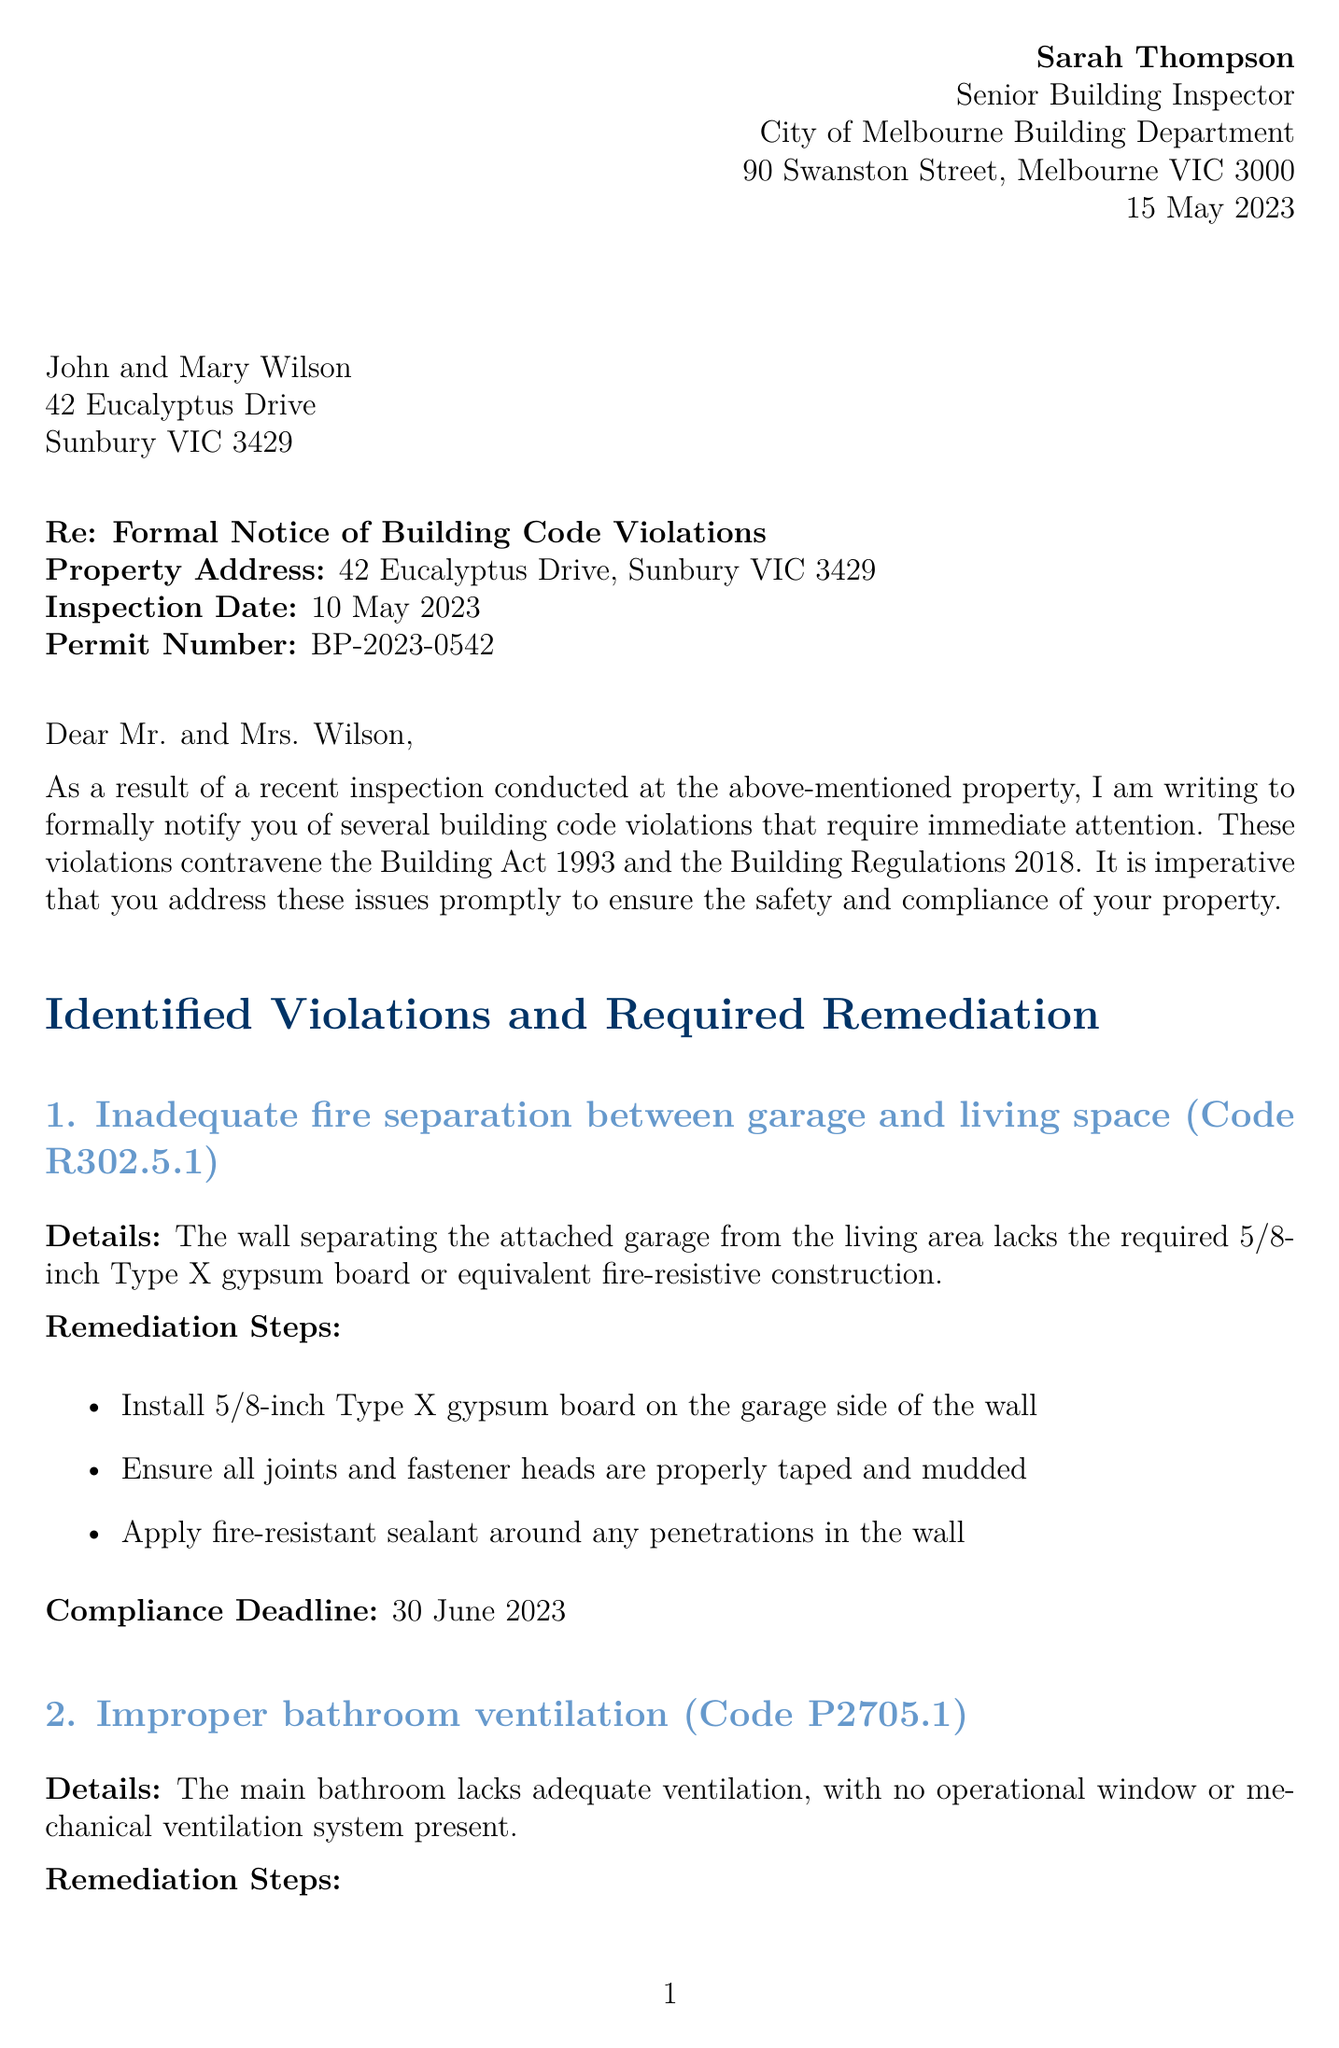What is the inspector's name? The inspector's name is listed at the top of the document.
Answer: Sarah Thompson What is the date of the letter? The date of the letter is indicated at the start of the document.
Answer: 15 May 2023 What is the property owner's name? The property owner's name is mentioned in the property details section.
Answer: John and Mary Wilson What is the code for the first violation? The first violation is labeled with a specific building code in the letter.
Answer: R302.5.1 What is the compliance deadline for the bathroom ventilation violation? The compliance deadline is specified in relation to the second violation.
Answer: 15 July 2023 How many remediation steps are required for the electrical outlets issue? The number of remediation steps can be counted from the section detailing that violation.
Answer: Three What action must be taken upon completion of the required remediation? The document specifies that a follow-up action is needed after remediation.
Answer: Schedule a follow-up inspection What could happen if the violations are not addressed by the deadlines? The letter outlines potential consequences for non-compliance.
Answer: Fines and legal proceedings What is the title of the inspector? The title of the inspector is stated in the document.
Answer: Senior Building Inspector 